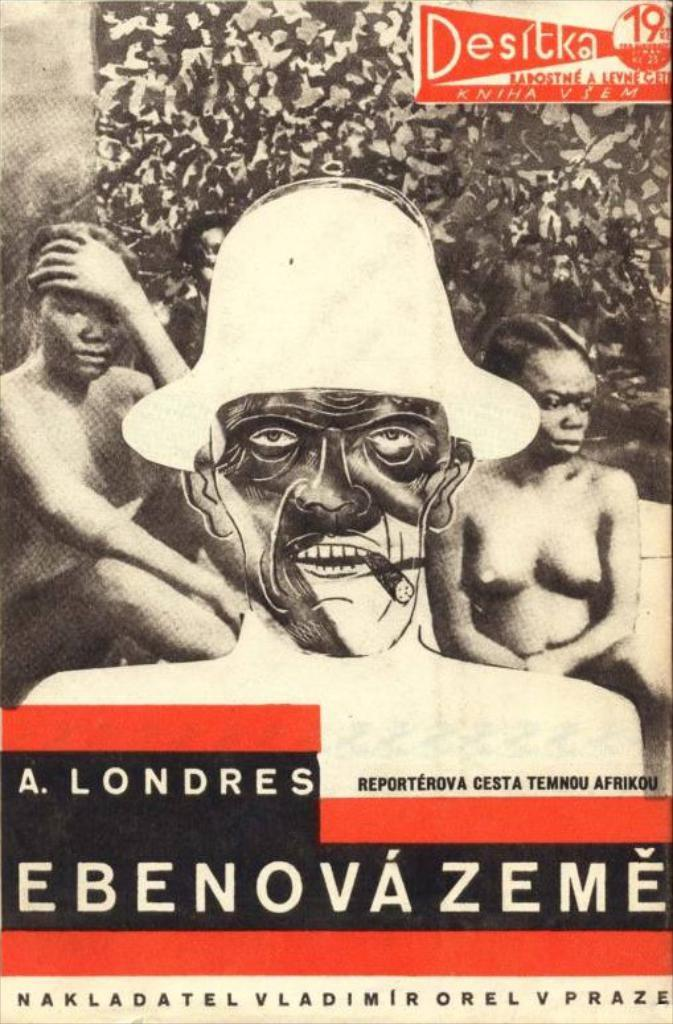What is the source of the image? The image appears to be from a book. Is there any text associated with the image? Yes, there is text at the bottom of the image. How many persons are present in the image? There are two persons on either side of the image. What discovery did the son make in the image? There is no son or discovery mentioned in the image. 